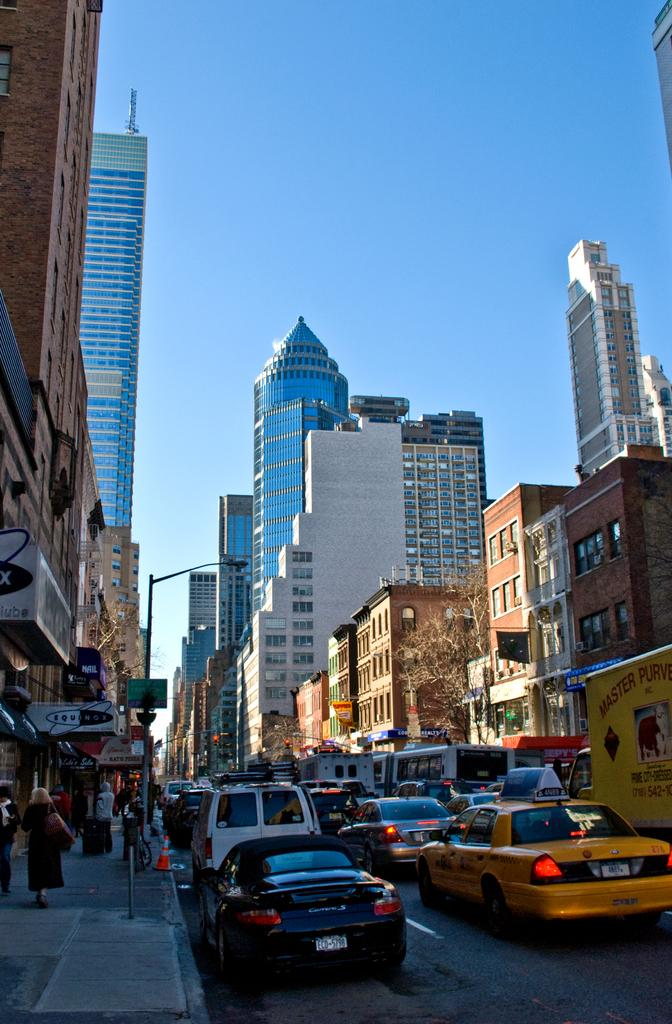Provide a one-sentence caption for the provided image. A street scene which contains a black car with the letters ECD on the licence plate. 